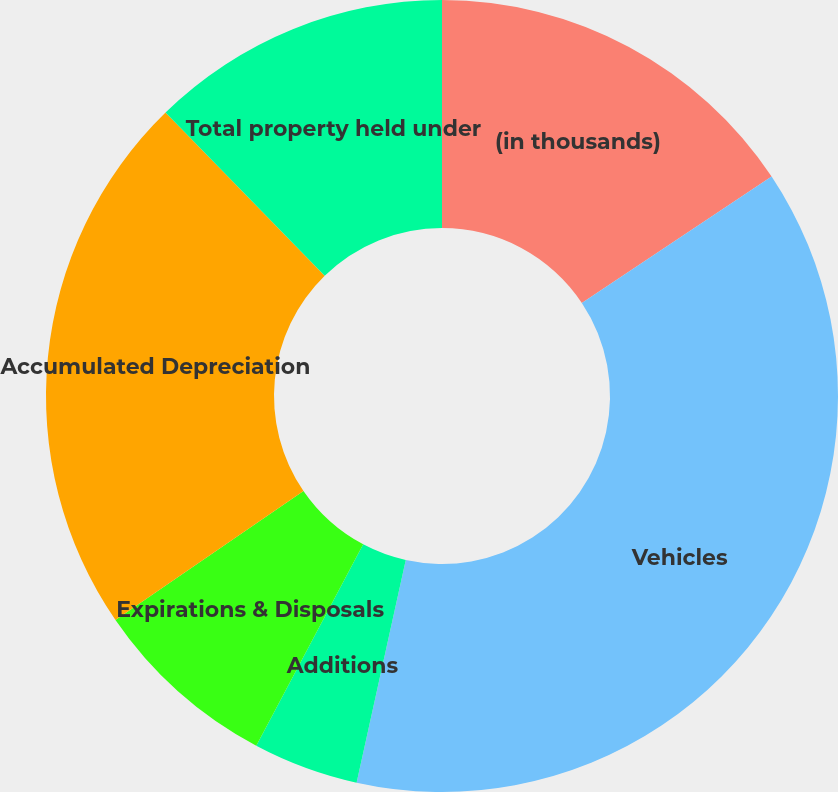<chart> <loc_0><loc_0><loc_500><loc_500><pie_chart><fcel>(in thousands)<fcel>Vehicles<fcel>Additions<fcel>Expirations & Disposals<fcel>Accumulated Depreciation<fcel>Total property held under<nl><fcel>15.65%<fcel>37.81%<fcel>4.31%<fcel>7.66%<fcel>22.27%<fcel>12.3%<nl></chart> 